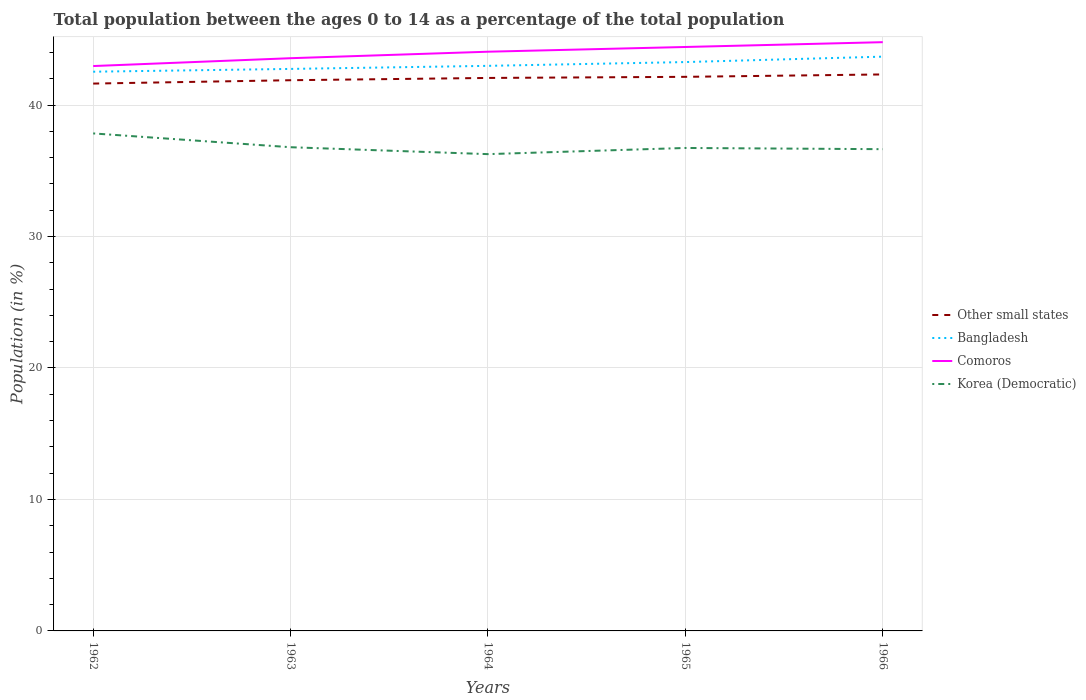Does the line corresponding to Other small states intersect with the line corresponding to Comoros?
Offer a very short reply. No. Across all years, what is the maximum percentage of the population ages 0 to 14 in Comoros?
Provide a succinct answer. 42.97. In which year was the percentage of the population ages 0 to 14 in Comoros maximum?
Give a very brief answer. 1962. What is the total percentage of the population ages 0 to 14 in Korea (Democratic) in the graph?
Your answer should be very brief. 0.15. What is the difference between the highest and the second highest percentage of the population ages 0 to 14 in Comoros?
Your response must be concise. 1.82. How many lines are there?
Ensure brevity in your answer.  4. Are the values on the major ticks of Y-axis written in scientific E-notation?
Ensure brevity in your answer.  No. Where does the legend appear in the graph?
Make the answer very short. Center right. How are the legend labels stacked?
Ensure brevity in your answer.  Vertical. What is the title of the graph?
Your answer should be compact. Total population between the ages 0 to 14 as a percentage of the total population. Does "Sao Tome and Principe" appear as one of the legend labels in the graph?
Provide a succinct answer. No. What is the label or title of the X-axis?
Your answer should be compact. Years. What is the Population (in %) of Other small states in 1962?
Ensure brevity in your answer.  41.63. What is the Population (in %) of Bangladesh in 1962?
Your answer should be compact. 42.54. What is the Population (in %) in Comoros in 1962?
Offer a very short reply. 42.97. What is the Population (in %) of Korea (Democratic) in 1962?
Your answer should be compact. 37.84. What is the Population (in %) of Other small states in 1963?
Provide a short and direct response. 41.89. What is the Population (in %) of Bangladesh in 1963?
Your answer should be compact. 42.75. What is the Population (in %) of Comoros in 1963?
Your answer should be very brief. 43.56. What is the Population (in %) of Korea (Democratic) in 1963?
Offer a very short reply. 36.79. What is the Population (in %) in Other small states in 1964?
Your response must be concise. 42.06. What is the Population (in %) of Bangladesh in 1964?
Keep it short and to the point. 42.98. What is the Population (in %) in Comoros in 1964?
Your response must be concise. 44.06. What is the Population (in %) in Korea (Democratic) in 1964?
Ensure brevity in your answer.  36.27. What is the Population (in %) of Other small states in 1965?
Ensure brevity in your answer.  42.15. What is the Population (in %) of Bangladesh in 1965?
Make the answer very short. 43.27. What is the Population (in %) in Comoros in 1965?
Your response must be concise. 44.42. What is the Population (in %) of Korea (Democratic) in 1965?
Make the answer very short. 36.74. What is the Population (in %) of Other small states in 1966?
Give a very brief answer. 42.33. What is the Population (in %) in Bangladesh in 1966?
Ensure brevity in your answer.  43.68. What is the Population (in %) in Comoros in 1966?
Ensure brevity in your answer.  44.78. What is the Population (in %) in Korea (Democratic) in 1966?
Your answer should be very brief. 36.64. Across all years, what is the maximum Population (in %) of Other small states?
Your answer should be compact. 42.33. Across all years, what is the maximum Population (in %) in Bangladesh?
Keep it short and to the point. 43.68. Across all years, what is the maximum Population (in %) of Comoros?
Offer a very short reply. 44.78. Across all years, what is the maximum Population (in %) of Korea (Democratic)?
Ensure brevity in your answer.  37.84. Across all years, what is the minimum Population (in %) in Other small states?
Offer a very short reply. 41.63. Across all years, what is the minimum Population (in %) in Bangladesh?
Keep it short and to the point. 42.54. Across all years, what is the minimum Population (in %) of Comoros?
Provide a short and direct response. 42.97. Across all years, what is the minimum Population (in %) in Korea (Democratic)?
Your answer should be very brief. 36.27. What is the total Population (in %) in Other small states in the graph?
Provide a succinct answer. 210.06. What is the total Population (in %) in Bangladesh in the graph?
Make the answer very short. 215.22. What is the total Population (in %) of Comoros in the graph?
Your response must be concise. 219.79. What is the total Population (in %) of Korea (Democratic) in the graph?
Your answer should be compact. 184.28. What is the difference between the Population (in %) of Other small states in 1962 and that in 1963?
Make the answer very short. -0.26. What is the difference between the Population (in %) of Bangladesh in 1962 and that in 1963?
Ensure brevity in your answer.  -0.21. What is the difference between the Population (in %) in Comoros in 1962 and that in 1963?
Keep it short and to the point. -0.6. What is the difference between the Population (in %) of Korea (Democratic) in 1962 and that in 1963?
Give a very brief answer. 1.05. What is the difference between the Population (in %) in Other small states in 1962 and that in 1964?
Provide a succinct answer. -0.43. What is the difference between the Population (in %) of Bangladesh in 1962 and that in 1964?
Offer a terse response. -0.45. What is the difference between the Population (in %) of Comoros in 1962 and that in 1964?
Ensure brevity in your answer.  -1.09. What is the difference between the Population (in %) in Korea (Democratic) in 1962 and that in 1964?
Your answer should be compact. 1.58. What is the difference between the Population (in %) of Other small states in 1962 and that in 1965?
Your response must be concise. -0.51. What is the difference between the Population (in %) in Bangladesh in 1962 and that in 1965?
Offer a terse response. -0.73. What is the difference between the Population (in %) of Comoros in 1962 and that in 1965?
Offer a terse response. -1.45. What is the difference between the Population (in %) of Korea (Democratic) in 1962 and that in 1965?
Your answer should be very brief. 1.11. What is the difference between the Population (in %) in Other small states in 1962 and that in 1966?
Offer a terse response. -0.69. What is the difference between the Population (in %) in Bangladesh in 1962 and that in 1966?
Your answer should be very brief. -1.15. What is the difference between the Population (in %) of Comoros in 1962 and that in 1966?
Your answer should be very brief. -1.82. What is the difference between the Population (in %) of Korea (Democratic) in 1962 and that in 1966?
Your answer should be very brief. 1.2. What is the difference between the Population (in %) of Other small states in 1963 and that in 1964?
Offer a very short reply. -0.17. What is the difference between the Population (in %) of Bangladesh in 1963 and that in 1964?
Give a very brief answer. -0.23. What is the difference between the Population (in %) in Comoros in 1963 and that in 1964?
Provide a succinct answer. -0.49. What is the difference between the Population (in %) of Korea (Democratic) in 1963 and that in 1964?
Give a very brief answer. 0.53. What is the difference between the Population (in %) in Other small states in 1963 and that in 1965?
Keep it short and to the point. -0.26. What is the difference between the Population (in %) of Bangladesh in 1963 and that in 1965?
Your answer should be very brief. -0.52. What is the difference between the Population (in %) of Comoros in 1963 and that in 1965?
Ensure brevity in your answer.  -0.85. What is the difference between the Population (in %) in Korea (Democratic) in 1963 and that in 1965?
Provide a succinct answer. 0.06. What is the difference between the Population (in %) in Other small states in 1963 and that in 1966?
Ensure brevity in your answer.  -0.44. What is the difference between the Population (in %) in Bangladesh in 1963 and that in 1966?
Your answer should be very brief. -0.93. What is the difference between the Population (in %) in Comoros in 1963 and that in 1966?
Keep it short and to the point. -1.22. What is the difference between the Population (in %) in Korea (Democratic) in 1963 and that in 1966?
Keep it short and to the point. 0.15. What is the difference between the Population (in %) in Other small states in 1964 and that in 1965?
Offer a very short reply. -0.08. What is the difference between the Population (in %) in Bangladesh in 1964 and that in 1965?
Provide a short and direct response. -0.29. What is the difference between the Population (in %) of Comoros in 1964 and that in 1965?
Make the answer very short. -0.36. What is the difference between the Population (in %) in Korea (Democratic) in 1964 and that in 1965?
Make the answer very short. -0.47. What is the difference between the Population (in %) of Other small states in 1964 and that in 1966?
Offer a very short reply. -0.27. What is the difference between the Population (in %) in Comoros in 1964 and that in 1966?
Offer a terse response. -0.73. What is the difference between the Population (in %) of Korea (Democratic) in 1964 and that in 1966?
Your answer should be compact. -0.38. What is the difference between the Population (in %) of Other small states in 1965 and that in 1966?
Keep it short and to the point. -0.18. What is the difference between the Population (in %) of Bangladesh in 1965 and that in 1966?
Keep it short and to the point. -0.41. What is the difference between the Population (in %) in Comoros in 1965 and that in 1966?
Your response must be concise. -0.37. What is the difference between the Population (in %) in Korea (Democratic) in 1965 and that in 1966?
Offer a very short reply. 0.09. What is the difference between the Population (in %) of Other small states in 1962 and the Population (in %) of Bangladesh in 1963?
Provide a short and direct response. -1.11. What is the difference between the Population (in %) in Other small states in 1962 and the Population (in %) in Comoros in 1963?
Provide a succinct answer. -1.93. What is the difference between the Population (in %) of Other small states in 1962 and the Population (in %) of Korea (Democratic) in 1963?
Offer a terse response. 4.84. What is the difference between the Population (in %) of Bangladesh in 1962 and the Population (in %) of Comoros in 1963?
Ensure brevity in your answer.  -1.03. What is the difference between the Population (in %) of Bangladesh in 1962 and the Population (in %) of Korea (Democratic) in 1963?
Provide a succinct answer. 5.74. What is the difference between the Population (in %) in Comoros in 1962 and the Population (in %) in Korea (Democratic) in 1963?
Provide a short and direct response. 6.17. What is the difference between the Population (in %) in Other small states in 1962 and the Population (in %) in Bangladesh in 1964?
Your answer should be compact. -1.35. What is the difference between the Population (in %) of Other small states in 1962 and the Population (in %) of Comoros in 1964?
Provide a short and direct response. -2.42. What is the difference between the Population (in %) in Other small states in 1962 and the Population (in %) in Korea (Democratic) in 1964?
Offer a very short reply. 5.37. What is the difference between the Population (in %) of Bangladesh in 1962 and the Population (in %) of Comoros in 1964?
Your response must be concise. -1.52. What is the difference between the Population (in %) of Bangladesh in 1962 and the Population (in %) of Korea (Democratic) in 1964?
Keep it short and to the point. 6.27. What is the difference between the Population (in %) of Comoros in 1962 and the Population (in %) of Korea (Democratic) in 1964?
Give a very brief answer. 6.7. What is the difference between the Population (in %) in Other small states in 1962 and the Population (in %) in Bangladesh in 1965?
Make the answer very short. -1.64. What is the difference between the Population (in %) in Other small states in 1962 and the Population (in %) in Comoros in 1965?
Your response must be concise. -2.78. What is the difference between the Population (in %) in Other small states in 1962 and the Population (in %) in Korea (Democratic) in 1965?
Keep it short and to the point. 4.9. What is the difference between the Population (in %) of Bangladesh in 1962 and the Population (in %) of Comoros in 1965?
Offer a very short reply. -1.88. What is the difference between the Population (in %) in Bangladesh in 1962 and the Population (in %) in Korea (Democratic) in 1965?
Your answer should be compact. 5.8. What is the difference between the Population (in %) in Comoros in 1962 and the Population (in %) in Korea (Democratic) in 1965?
Offer a terse response. 6.23. What is the difference between the Population (in %) in Other small states in 1962 and the Population (in %) in Bangladesh in 1966?
Your response must be concise. -2.05. What is the difference between the Population (in %) in Other small states in 1962 and the Population (in %) in Comoros in 1966?
Offer a terse response. -3.15. What is the difference between the Population (in %) of Other small states in 1962 and the Population (in %) of Korea (Democratic) in 1966?
Your answer should be compact. 4.99. What is the difference between the Population (in %) in Bangladesh in 1962 and the Population (in %) in Comoros in 1966?
Your answer should be compact. -2.25. What is the difference between the Population (in %) of Bangladesh in 1962 and the Population (in %) of Korea (Democratic) in 1966?
Keep it short and to the point. 5.89. What is the difference between the Population (in %) of Comoros in 1962 and the Population (in %) of Korea (Democratic) in 1966?
Ensure brevity in your answer.  6.32. What is the difference between the Population (in %) of Other small states in 1963 and the Population (in %) of Bangladesh in 1964?
Your answer should be very brief. -1.09. What is the difference between the Population (in %) in Other small states in 1963 and the Population (in %) in Comoros in 1964?
Your answer should be compact. -2.17. What is the difference between the Population (in %) of Other small states in 1963 and the Population (in %) of Korea (Democratic) in 1964?
Your answer should be very brief. 5.62. What is the difference between the Population (in %) in Bangladesh in 1963 and the Population (in %) in Comoros in 1964?
Your answer should be very brief. -1.31. What is the difference between the Population (in %) of Bangladesh in 1963 and the Population (in %) of Korea (Democratic) in 1964?
Give a very brief answer. 6.48. What is the difference between the Population (in %) of Comoros in 1963 and the Population (in %) of Korea (Democratic) in 1964?
Keep it short and to the point. 7.3. What is the difference between the Population (in %) of Other small states in 1963 and the Population (in %) of Bangladesh in 1965?
Provide a short and direct response. -1.38. What is the difference between the Population (in %) of Other small states in 1963 and the Population (in %) of Comoros in 1965?
Provide a succinct answer. -2.53. What is the difference between the Population (in %) of Other small states in 1963 and the Population (in %) of Korea (Democratic) in 1965?
Provide a short and direct response. 5.15. What is the difference between the Population (in %) in Bangladesh in 1963 and the Population (in %) in Comoros in 1965?
Your response must be concise. -1.67. What is the difference between the Population (in %) in Bangladesh in 1963 and the Population (in %) in Korea (Democratic) in 1965?
Give a very brief answer. 6.01. What is the difference between the Population (in %) in Comoros in 1963 and the Population (in %) in Korea (Democratic) in 1965?
Your answer should be compact. 6.83. What is the difference between the Population (in %) in Other small states in 1963 and the Population (in %) in Bangladesh in 1966?
Give a very brief answer. -1.79. What is the difference between the Population (in %) in Other small states in 1963 and the Population (in %) in Comoros in 1966?
Your answer should be compact. -2.89. What is the difference between the Population (in %) in Other small states in 1963 and the Population (in %) in Korea (Democratic) in 1966?
Provide a short and direct response. 5.25. What is the difference between the Population (in %) in Bangladesh in 1963 and the Population (in %) in Comoros in 1966?
Your answer should be very brief. -2.03. What is the difference between the Population (in %) of Bangladesh in 1963 and the Population (in %) of Korea (Democratic) in 1966?
Ensure brevity in your answer.  6.1. What is the difference between the Population (in %) in Comoros in 1963 and the Population (in %) in Korea (Democratic) in 1966?
Keep it short and to the point. 6.92. What is the difference between the Population (in %) in Other small states in 1964 and the Population (in %) in Bangladesh in 1965?
Your response must be concise. -1.21. What is the difference between the Population (in %) in Other small states in 1964 and the Population (in %) in Comoros in 1965?
Give a very brief answer. -2.36. What is the difference between the Population (in %) of Other small states in 1964 and the Population (in %) of Korea (Democratic) in 1965?
Offer a very short reply. 5.33. What is the difference between the Population (in %) of Bangladesh in 1964 and the Population (in %) of Comoros in 1965?
Give a very brief answer. -1.44. What is the difference between the Population (in %) of Bangladesh in 1964 and the Population (in %) of Korea (Democratic) in 1965?
Your answer should be compact. 6.25. What is the difference between the Population (in %) of Comoros in 1964 and the Population (in %) of Korea (Democratic) in 1965?
Your answer should be very brief. 7.32. What is the difference between the Population (in %) in Other small states in 1964 and the Population (in %) in Bangladesh in 1966?
Provide a succinct answer. -1.62. What is the difference between the Population (in %) in Other small states in 1964 and the Population (in %) in Comoros in 1966?
Your answer should be compact. -2.72. What is the difference between the Population (in %) in Other small states in 1964 and the Population (in %) in Korea (Democratic) in 1966?
Your response must be concise. 5.42. What is the difference between the Population (in %) in Bangladesh in 1964 and the Population (in %) in Comoros in 1966?
Your response must be concise. -1.8. What is the difference between the Population (in %) of Bangladesh in 1964 and the Population (in %) of Korea (Democratic) in 1966?
Ensure brevity in your answer.  6.34. What is the difference between the Population (in %) of Comoros in 1964 and the Population (in %) of Korea (Democratic) in 1966?
Provide a short and direct response. 7.41. What is the difference between the Population (in %) of Other small states in 1965 and the Population (in %) of Bangladesh in 1966?
Your answer should be compact. -1.54. What is the difference between the Population (in %) of Other small states in 1965 and the Population (in %) of Comoros in 1966?
Offer a very short reply. -2.64. What is the difference between the Population (in %) of Other small states in 1965 and the Population (in %) of Korea (Democratic) in 1966?
Provide a short and direct response. 5.5. What is the difference between the Population (in %) of Bangladesh in 1965 and the Population (in %) of Comoros in 1966?
Your answer should be compact. -1.51. What is the difference between the Population (in %) in Bangladesh in 1965 and the Population (in %) in Korea (Democratic) in 1966?
Your answer should be compact. 6.63. What is the difference between the Population (in %) of Comoros in 1965 and the Population (in %) of Korea (Democratic) in 1966?
Offer a very short reply. 7.77. What is the average Population (in %) of Other small states per year?
Make the answer very short. 42.01. What is the average Population (in %) in Bangladesh per year?
Provide a short and direct response. 43.04. What is the average Population (in %) in Comoros per year?
Provide a succinct answer. 43.96. What is the average Population (in %) of Korea (Democratic) per year?
Offer a terse response. 36.86. In the year 1962, what is the difference between the Population (in %) of Other small states and Population (in %) of Bangladesh?
Offer a very short reply. -0.9. In the year 1962, what is the difference between the Population (in %) of Other small states and Population (in %) of Comoros?
Keep it short and to the point. -1.33. In the year 1962, what is the difference between the Population (in %) of Other small states and Population (in %) of Korea (Democratic)?
Provide a short and direct response. 3.79. In the year 1962, what is the difference between the Population (in %) of Bangladesh and Population (in %) of Comoros?
Your answer should be very brief. -0.43. In the year 1962, what is the difference between the Population (in %) in Bangladesh and Population (in %) in Korea (Democratic)?
Offer a terse response. 4.69. In the year 1962, what is the difference between the Population (in %) in Comoros and Population (in %) in Korea (Democratic)?
Your response must be concise. 5.12. In the year 1963, what is the difference between the Population (in %) in Other small states and Population (in %) in Bangladesh?
Provide a succinct answer. -0.86. In the year 1963, what is the difference between the Population (in %) in Other small states and Population (in %) in Comoros?
Ensure brevity in your answer.  -1.67. In the year 1963, what is the difference between the Population (in %) in Other small states and Population (in %) in Korea (Democratic)?
Offer a terse response. 5.1. In the year 1963, what is the difference between the Population (in %) in Bangladesh and Population (in %) in Comoros?
Give a very brief answer. -0.81. In the year 1963, what is the difference between the Population (in %) in Bangladesh and Population (in %) in Korea (Democratic)?
Your response must be concise. 5.96. In the year 1963, what is the difference between the Population (in %) of Comoros and Population (in %) of Korea (Democratic)?
Give a very brief answer. 6.77. In the year 1964, what is the difference between the Population (in %) in Other small states and Population (in %) in Bangladesh?
Keep it short and to the point. -0.92. In the year 1964, what is the difference between the Population (in %) in Other small states and Population (in %) in Comoros?
Give a very brief answer. -2. In the year 1964, what is the difference between the Population (in %) in Other small states and Population (in %) in Korea (Democratic)?
Make the answer very short. 5.8. In the year 1964, what is the difference between the Population (in %) of Bangladesh and Population (in %) of Comoros?
Your answer should be very brief. -1.08. In the year 1964, what is the difference between the Population (in %) of Bangladesh and Population (in %) of Korea (Democratic)?
Offer a terse response. 6.72. In the year 1964, what is the difference between the Population (in %) of Comoros and Population (in %) of Korea (Democratic)?
Offer a terse response. 7.79. In the year 1965, what is the difference between the Population (in %) in Other small states and Population (in %) in Bangladesh?
Offer a terse response. -1.12. In the year 1965, what is the difference between the Population (in %) of Other small states and Population (in %) of Comoros?
Ensure brevity in your answer.  -2.27. In the year 1965, what is the difference between the Population (in %) in Other small states and Population (in %) in Korea (Democratic)?
Your answer should be compact. 5.41. In the year 1965, what is the difference between the Population (in %) in Bangladesh and Population (in %) in Comoros?
Provide a short and direct response. -1.15. In the year 1965, what is the difference between the Population (in %) in Bangladesh and Population (in %) in Korea (Democratic)?
Your answer should be very brief. 6.53. In the year 1965, what is the difference between the Population (in %) in Comoros and Population (in %) in Korea (Democratic)?
Your response must be concise. 7.68. In the year 1966, what is the difference between the Population (in %) in Other small states and Population (in %) in Bangladesh?
Offer a very short reply. -1.35. In the year 1966, what is the difference between the Population (in %) of Other small states and Population (in %) of Comoros?
Your response must be concise. -2.45. In the year 1966, what is the difference between the Population (in %) in Other small states and Population (in %) in Korea (Democratic)?
Your answer should be compact. 5.69. In the year 1966, what is the difference between the Population (in %) in Bangladesh and Population (in %) in Comoros?
Offer a terse response. -1.1. In the year 1966, what is the difference between the Population (in %) in Bangladesh and Population (in %) in Korea (Democratic)?
Provide a succinct answer. 7.04. In the year 1966, what is the difference between the Population (in %) in Comoros and Population (in %) in Korea (Democratic)?
Ensure brevity in your answer.  8.14. What is the ratio of the Population (in %) in Comoros in 1962 to that in 1963?
Keep it short and to the point. 0.99. What is the ratio of the Population (in %) of Korea (Democratic) in 1962 to that in 1963?
Your answer should be compact. 1.03. What is the ratio of the Population (in %) of Other small states in 1962 to that in 1964?
Your answer should be compact. 0.99. What is the ratio of the Population (in %) in Bangladesh in 1962 to that in 1964?
Keep it short and to the point. 0.99. What is the ratio of the Population (in %) in Comoros in 1962 to that in 1964?
Provide a succinct answer. 0.98. What is the ratio of the Population (in %) of Korea (Democratic) in 1962 to that in 1964?
Your answer should be very brief. 1.04. What is the ratio of the Population (in %) of Other small states in 1962 to that in 1965?
Provide a short and direct response. 0.99. What is the ratio of the Population (in %) in Bangladesh in 1962 to that in 1965?
Your response must be concise. 0.98. What is the ratio of the Population (in %) of Comoros in 1962 to that in 1965?
Provide a succinct answer. 0.97. What is the ratio of the Population (in %) of Korea (Democratic) in 1962 to that in 1965?
Keep it short and to the point. 1.03. What is the ratio of the Population (in %) in Other small states in 1962 to that in 1966?
Your response must be concise. 0.98. What is the ratio of the Population (in %) in Bangladesh in 1962 to that in 1966?
Give a very brief answer. 0.97. What is the ratio of the Population (in %) of Comoros in 1962 to that in 1966?
Offer a terse response. 0.96. What is the ratio of the Population (in %) in Korea (Democratic) in 1962 to that in 1966?
Keep it short and to the point. 1.03. What is the ratio of the Population (in %) of Other small states in 1963 to that in 1964?
Provide a short and direct response. 1. What is the ratio of the Population (in %) in Bangladesh in 1963 to that in 1964?
Keep it short and to the point. 0.99. What is the ratio of the Population (in %) of Comoros in 1963 to that in 1964?
Give a very brief answer. 0.99. What is the ratio of the Population (in %) of Korea (Democratic) in 1963 to that in 1964?
Keep it short and to the point. 1.01. What is the ratio of the Population (in %) in Bangladesh in 1963 to that in 1965?
Give a very brief answer. 0.99. What is the ratio of the Population (in %) of Comoros in 1963 to that in 1965?
Keep it short and to the point. 0.98. What is the ratio of the Population (in %) of Other small states in 1963 to that in 1966?
Keep it short and to the point. 0.99. What is the ratio of the Population (in %) of Bangladesh in 1963 to that in 1966?
Your response must be concise. 0.98. What is the ratio of the Population (in %) in Comoros in 1963 to that in 1966?
Keep it short and to the point. 0.97. What is the ratio of the Population (in %) of Korea (Democratic) in 1963 to that in 1966?
Your response must be concise. 1. What is the ratio of the Population (in %) of Other small states in 1964 to that in 1965?
Your answer should be compact. 1. What is the ratio of the Population (in %) of Bangladesh in 1964 to that in 1965?
Ensure brevity in your answer.  0.99. What is the ratio of the Population (in %) of Korea (Democratic) in 1964 to that in 1965?
Offer a terse response. 0.99. What is the ratio of the Population (in %) in Other small states in 1964 to that in 1966?
Provide a short and direct response. 0.99. What is the ratio of the Population (in %) of Bangladesh in 1964 to that in 1966?
Make the answer very short. 0.98. What is the ratio of the Population (in %) of Comoros in 1964 to that in 1966?
Offer a very short reply. 0.98. What is the ratio of the Population (in %) in Korea (Democratic) in 1964 to that in 1966?
Offer a very short reply. 0.99. What is the ratio of the Population (in %) of Other small states in 1965 to that in 1966?
Your response must be concise. 1. What is the ratio of the Population (in %) of Bangladesh in 1965 to that in 1966?
Offer a terse response. 0.99. What is the ratio of the Population (in %) in Comoros in 1965 to that in 1966?
Make the answer very short. 0.99. What is the difference between the highest and the second highest Population (in %) of Other small states?
Your answer should be compact. 0.18. What is the difference between the highest and the second highest Population (in %) of Bangladesh?
Ensure brevity in your answer.  0.41. What is the difference between the highest and the second highest Population (in %) in Comoros?
Offer a very short reply. 0.37. What is the difference between the highest and the lowest Population (in %) of Other small states?
Make the answer very short. 0.69. What is the difference between the highest and the lowest Population (in %) of Bangladesh?
Your answer should be very brief. 1.15. What is the difference between the highest and the lowest Population (in %) in Comoros?
Offer a terse response. 1.82. What is the difference between the highest and the lowest Population (in %) in Korea (Democratic)?
Give a very brief answer. 1.58. 